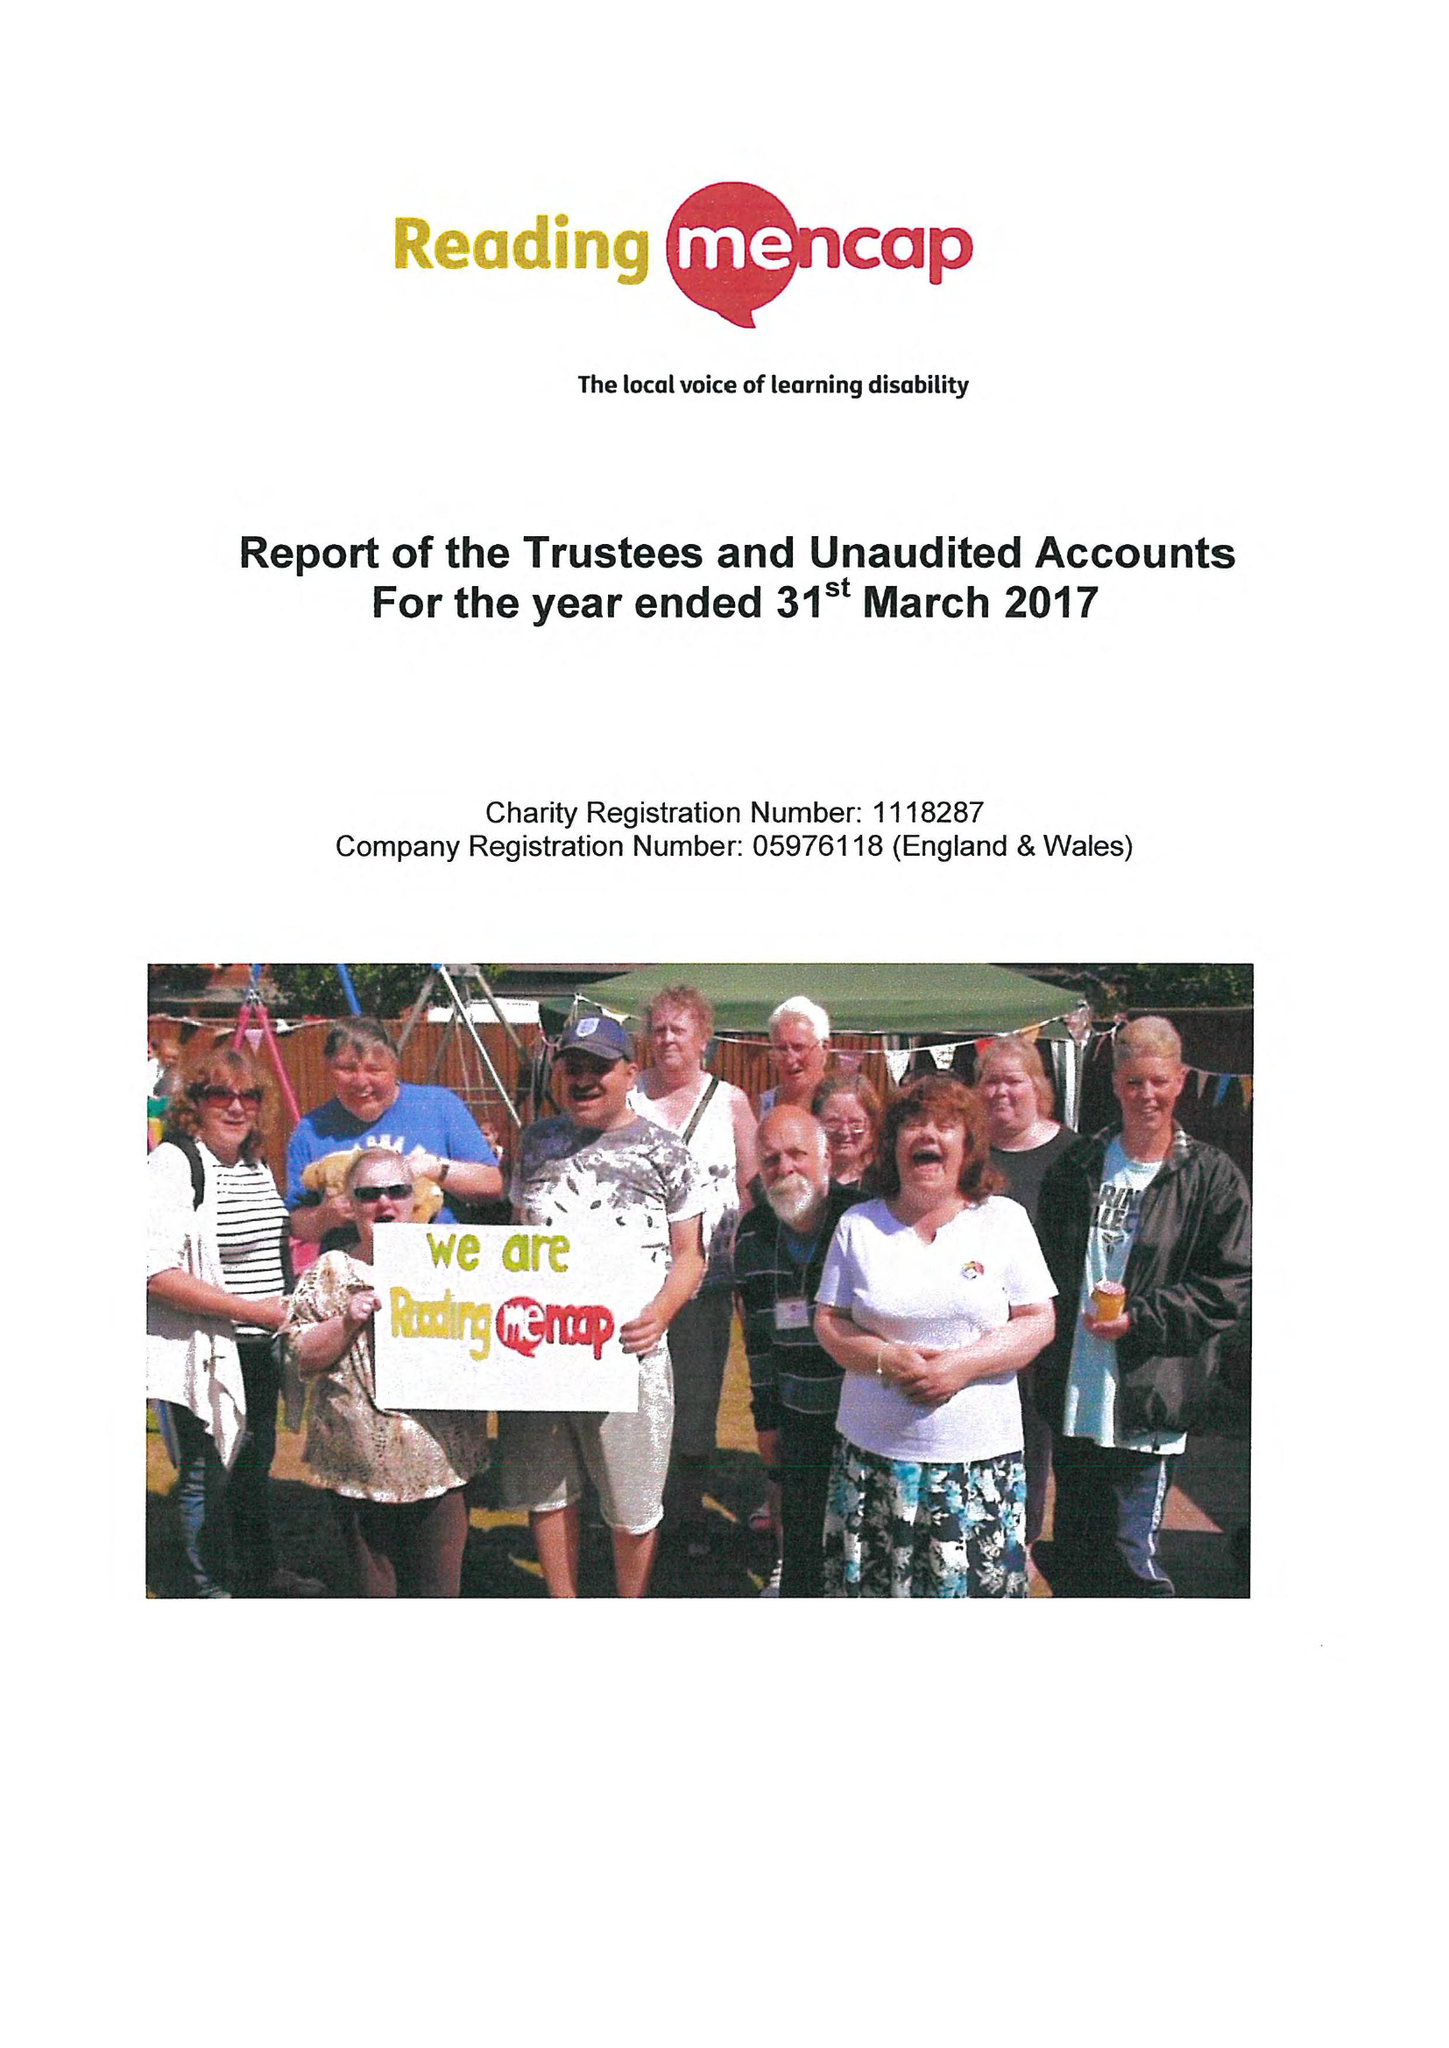What is the value for the address__postcode?
Answer the question using a single word or phrase. RG1 5PE 